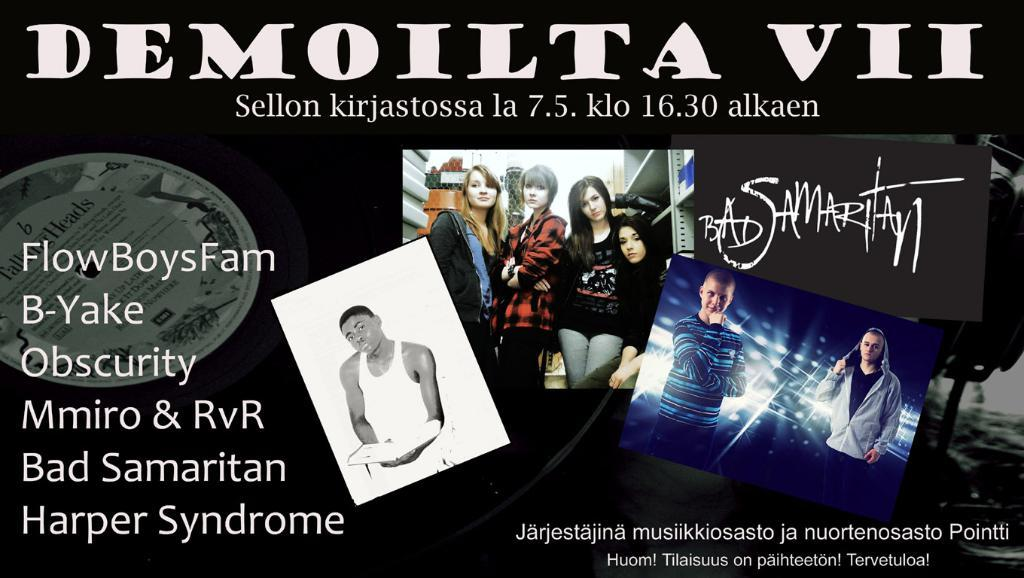<image>
Summarize the visual content of the image. Poster for Demolita VII featuring Obscurity and Harper Syndrome. 